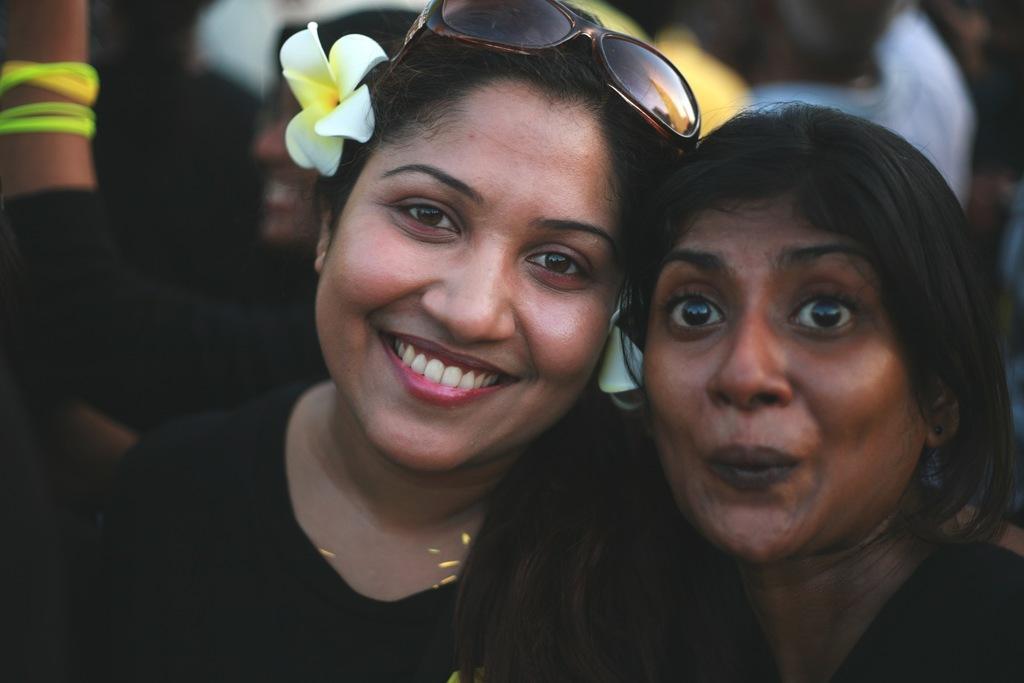How would you summarize this image in a sentence or two? In this picture I can observe two women. Both of them are smiling. I can observe a flower in the ear of one of the women. The background is blurred. 